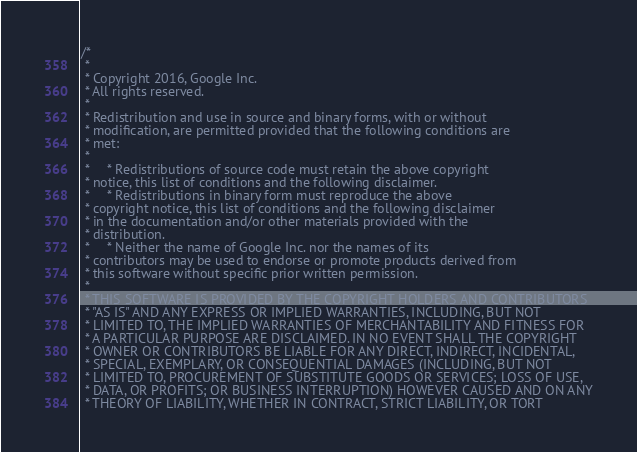Convert code to text. <code><loc_0><loc_0><loc_500><loc_500><_C_>/*
 *
 * Copyright 2016, Google Inc.
 * All rights reserved.
 *
 * Redistribution and use in source and binary forms, with or without
 * modification, are permitted provided that the following conditions are
 * met:
 *
 *     * Redistributions of source code must retain the above copyright
 * notice, this list of conditions and the following disclaimer.
 *     * Redistributions in binary form must reproduce the above
 * copyright notice, this list of conditions and the following disclaimer
 * in the documentation and/or other materials provided with the
 * distribution.
 *     * Neither the name of Google Inc. nor the names of its
 * contributors may be used to endorse or promote products derived from
 * this software without specific prior written permission.
 *
 * THIS SOFTWARE IS PROVIDED BY THE COPYRIGHT HOLDERS AND CONTRIBUTORS
 * "AS IS" AND ANY EXPRESS OR IMPLIED WARRANTIES, INCLUDING, BUT NOT
 * LIMITED TO, THE IMPLIED WARRANTIES OF MERCHANTABILITY AND FITNESS FOR
 * A PARTICULAR PURPOSE ARE DISCLAIMED. IN NO EVENT SHALL THE COPYRIGHT
 * OWNER OR CONTRIBUTORS BE LIABLE FOR ANY DIRECT, INDIRECT, INCIDENTAL,
 * SPECIAL, EXEMPLARY, OR CONSEQUENTIAL DAMAGES (INCLUDING, BUT NOT
 * LIMITED TO, PROCUREMENT OF SUBSTITUTE GOODS OR SERVICES; LOSS OF USE,
 * DATA, OR PROFITS; OR BUSINESS INTERRUPTION) HOWEVER CAUSED AND ON ANY
 * THEORY OF LIABILITY, WHETHER IN CONTRACT, STRICT LIABILITY, OR TORT</code> 